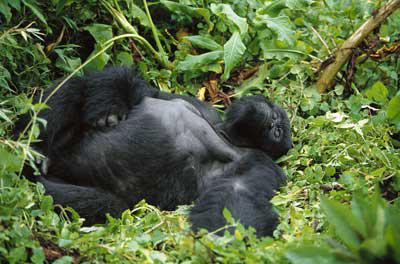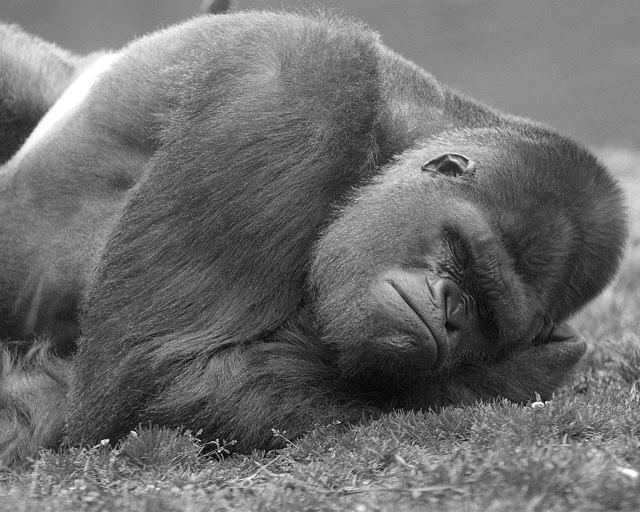The first image is the image on the left, the second image is the image on the right. For the images displayed, is the sentence "There are two gorillas laying down" factually correct? Answer yes or no. Yes. The first image is the image on the left, the second image is the image on the right. For the images displayed, is the sentence "The right image contains a gorilla lying on the grass with its head facing forward and the top of its head on the right." factually correct? Answer yes or no. Yes. 